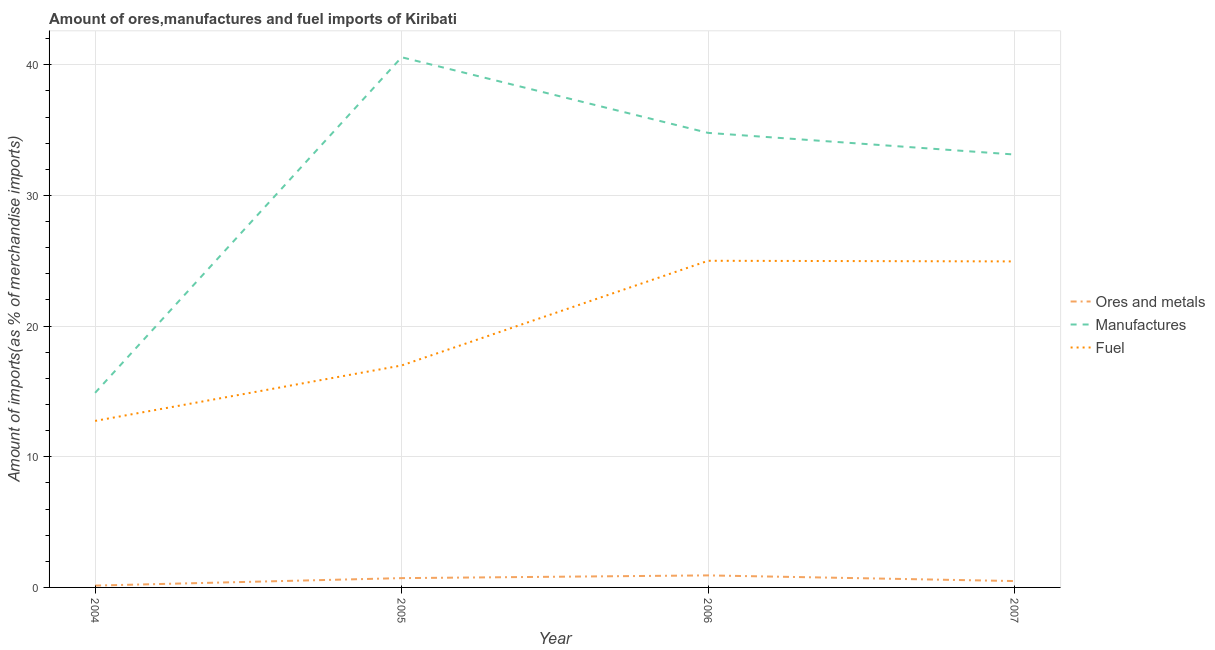How many different coloured lines are there?
Provide a succinct answer. 3. Does the line corresponding to percentage of manufactures imports intersect with the line corresponding to percentage of ores and metals imports?
Give a very brief answer. No. Is the number of lines equal to the number of legend labels?
Offer a terse response. Yes. What is the percentage of fuel imports in 2005?
Offer a terse response. 16.99. Across all years, what is the maximum percentage of manufactures imports?
Provide a succinct answer. 40.58. Across all years, what is the minimum percentage of ores and metals imports?
Your answer should be very brief. 0.14. What is the total percentage of manufactures imports in the graph?
Ensure brevity in your answer.  123.4. What is the difference between the percentage of ores and metals imports in 2004 and that in 2006?
Offer a terse response. -0.78. What is the difference between the percentage of fuel imports in 2007 and the percentage of manufactures imports in 2006?
Your response must be concise. -9.84. What is the average percentage of fuel imports per year?
Provide a succinct answer. 19.92. In the year 2004, what is the difference between the percentage of ores and metals imports and percentage of manufactures imports?
Provide a succinct answer. -14.75. What is the ratio of the percentage of fuel imports in 2004 to that in 2005?
Keep it short and to the point. 0.75. Is the percentage of manufactures imports in 2005 less than that in 2007?
Your answer should be compact. No. Is the difference between the percentage of ores and metals imports in 2005 and 2006 greater than the difference between the percentage of manufactures imports in 2005 and 2006?
Ensure brevity in your answer.  No. What is the difference between the highest and the second highest percentage of ores and metals imports?
Provide a short and direct response. 0.21. What is the difference between the highest and the lowest percentage of ores and metals imports?
Keep it short and to the point. 0.78. In how many years, is the percentage of fuel imports greater than the average percentage of fuel imports taken over all years?
Keep it short and to the point. 2. Is the sum of the percentage of ores and metals imports in 2006 and 2007 greater than the maximum percentage of fuel imports across all years?
Offer a terse response. No. Does the percentage of manufactures imports monotonically increase over the years?
Keep it short and to the point. No. Is the percentage of manufactures imports strictly less than the percentage of ores and metals imports over the years?
Give a very brief answer. No. How many lines are there?
Provide a succinct answer. 3. How many years are there in the graph?
Offer a very short reply. 4. What is the difference between two consecutive major ticks on the Y-axis?
Give a very brief answer. 10. Are the values on the major ticks of Y-axis written in scientific E-notation?
Offer a very short reply. No. Does the graph contain grids?
Your response must be concise. Yes. How many legend labels are there?
Keep it short and to the point. 3. What is the title of the graph?
Your response must be concise. Amount of ores,manufactures and fuel imports of Kiribati. Does "Textiles and clothing" appear as one of the legend labels in the graph?
Provide a succinct answer. No. What is the label or title of the X-axis?
Your answer should be compact. Year. What is the label or title of the Y-axis?
Give a very brief answer. Amount of imports(as % of merchandise imports). What is the Amount of imports(as % of merchandise imports) in Ores and metals in 2004?
Your response must be concise. 0.14. What is the Amount of imports(as % of merchandise imports) in Manufactures in 2004?
Provide a succinct answer. 14.89. What is the Amount of imports(as % of merchandise imports) of Fuel in 2004?
Your answer should be compact. 12.75. What is the Amount of imports(as % of merchandise imports) in Ores and metals in 2005?
Your answer should be very brief. 0.71. What is the Amount of imports(as % of merchandise imports) of Manufactures in 2005?
Give a very brief answer. 40.58. What is the Amount of imports(as % of merchandise imports) of Fuel in 2005?
Your answer should be very brief. 16.99. What is the Amount of imports(as % of merchandise imports) of Ores and metals in 2006?
Ensure brevity in your answer.  0.92. What is the Amount of imports(as % of merchandise imports) in Manufactures in 2006?
Provide a short and direct response. 34.79. What is the Amount of imports(as % of merchandise imports) of Fuel in 2006?
Your response must be concise. 25. What is the Amount of imports(as % of merchandise imports) of Ores and metals in 2007?
Your response must be concise. 0.49. What is the Amount of imports(as % of merchandise imports) in Manufactures in 2007?
Your answer should be very brief. 33.13. What is the Amount of imports(as % of merchandise imports) of Fuel in 2007?
Make the answer very short. 24.95. Across all years, what is the maximum Amount of imports(as % of merchandise imports) of Ores and metals?
Offer a terse response. 0.92. Across all years, what is the maximum Amount of imports(as % of merchandise imports) of Manufactures?
Your answer should be compact. 40.58. Across all years, what is the maximum Amount of imports(as % of merchandise imports) in Fuel?
Make the answer very short. 25. Across all years, what is the minimum Amount of imports(as % of merchandise imports) of Ores and metals?
Keep it short and to the point. 0.14. Across all years, what is the minimum Amount of imports(as % of merchandise imports) of Manufactures?
Your answer should be very brief. 14.89. Across all years, what is the minimum Amount of imports(as % of merchandise imports) in Fuel?
Provide a short and direct response. 12.75. What is the total Amount of imports(as % of merchandise imports) of Ores and metals in the graph?
Offer a terse response. 2.26. What is the total Amount of imports(as % of merchandise imports) in Manufactures in the graph?
Provide a short and direct response. 123.4. What is the total Amount of imports(as % of merchandise imports) of Fuel in the graph?
Make the answer very short. 79.69. What is the difference between the Amount of imports(as % of merchandise imports) in Ores and metals in 2004 and that in 2005?
Your answer should be compact. -0.57. What is the difference between the Amount of imports(as % of merchandise imports) in Manufactures in 2004 and that in 2005?
Provide a succinct answer. -25.69. What is the difference between the Amount of imports(as % of merchandise imports) of Fuel in 2004 and that in 2005?
Keep it short and to the point. -4.24. What is the difference between the Amount of imports(as % of merchandise imports) of Ores and metals in 2004 and that in 2006?
Provide a short and direct response. -0.78. What is the difference between the Amount of imports(as % of merchandise imports) of Manufactures in 2004 and that in 2006?
Provide a short and direct response. -19.9. What is the difference between the Amount of imports(as % of merchandise imports) in Fuel in 2004 and that in 2006?
Your answer should be compact. -12.26. What is the difference between the Amount of imports(as % of merchandise imports) of Ores and metals in 2004 and that in 2007?
Provide a succinct answer. -0.35. What is the difference between the Amount of imports(as % of merchandise imports) of Manufactures in 2004 and that in 2007?
Your answer should be compact. -18.24. What is the difference between the Amount of imports(as % of merchandise imports) of Fuel in 2004 and that in 2007?
Give a very brief answer. -12.21. What is the difference between the Amount of imports(as % of merchandise imports) of Ores and metals in 2005 and that in 2006?
Your answer should be very brief. -0.21. What is the difference between the Amount of imports(as % of merchandise imports) in Manufactures in 2005 and that in 2006?
Ensure brevity in your answer.  5.79. What is the difference between the Amount of imports(as % of merchandise imports) of Fuel in 2005 and that in 2006?
Your response must be concise. -8.01. What is the difference between the Amount of imports(as % of merchandise imports) of Ores and metals in 2005 and that in 2007?
Offer a very short reply. 0.22. What is the difference between the Amount of imports(as % of merchandise imports) of Manufactures in 2005 and that in 2007?
Your response must be concise. 7.45. What is the difference between the Amount of imports(as % of merchandise imports) of Fuel in 2005 and that in 2007?
Give a very brief answer. -7.96. What is the difference between the Amount of imports(as % of merchandise imports) of Ores and metals in 2006 and that in 2007?
Ensure brevity in your answer.  0.43. What is the difference between the Amount of imports(as % of merchandise imports) in Manufactures in 2006 and that in 2007?
Your response must be concise. 1.66. What is the difference between the Amount of imports(as % of merchandise imports) in Fuel in 2006 and that in 2007?
Ensure brevity in your answer.  0.05. What is the difference between the Amount of imports(as % of merchandise imports) in Ores and metals in 2004 and the Amount of imports(as % of merchandise imports) in Manufactures in 2005?
Offer a terse response. -40.44. What is the difference between the Amount of imports(as % of merchandise imports) in Ores and metals in 2004 and the Amount of imports(as % of merchandise imports) in Fuel in 2005?
Your answer should be very brief. -16.85. What is the difference between the Amount of imports(as % of merchandise imports) of Manufactures in 2004 and the Amount of imports(as % of merchandise imports) of Fuel in 2005?
Make the answer very short. -2.09. What is the difference between the Amount of imports(as % of merchandise imports) of Ores and metals in 2004 and the Amount of imports(as % of merchandise imports) of Manufactures in 2006?
Ensure brevity in your answer.  -34.65. What is the difference between the Amount of imports(as % of merchandise imports) of Ores and metals in 2004 and the Amount of imports(as % of merchandise imports) of Fuel in 2006?
Provide a short and direct response. -24.86. What is the difference between the Amount of imports(as % of merchandise imports) in Manufactures in 2004 and the Amount of imports(as % of merchandise imports) in Fuel in 2006?
Your answer should be very brief. -10.11. What is the difference between the Amount of imports(as % of merchandise imports) of Ores and metals in 2004 and the Amount of imports(as % of merchandise imports) of Manufactures in 2007?
Offer a terse response. -32.99. What is the difference between the Amount of imports(as % of merchandise imports) in Ores and metals in 2004 and the Amount of imports(as % of merchandise imports) in Fuel in 2007?
Your answer should be very brief. -24.81. What is the difference between the Amount of imports(as % of merchandise imports) of Manufactures in 2004 and the Amount of imports(as % of merchandise imports) of Fuel in 2007?
Offer a terse response. -10.06. What is the difference between the Amount of imports(as % of merchandise imports) in Ores and metals in 2005 and the Amount of imports(as % of merchandise imports) in Manufactures in 2006?
Your answer should be compact. -34.08. What is the difference between the Amount of imports(as % of merchandise imports) in Ores and metals in 2005 and the Amount of imports(as % of merchandise imports) in Fuel in 2006?
Offer a very short reply. -24.29. What is the difference between the Amount of imports(as % of merchandise imports) of Manufactures in 2005 and the Amount of imports(as % of merchandise imports) of Fuel in 2006?
Provide a succinct answer. 15.58. What is the difference between the Amount of imports(as % of merchandise imports) in Ores and metals in 2005 and the Amount of imports(as % of merchandise imports) in Manufactures in 2007?
Your response must be concise. -32.42. What is the difference between the Amount of imports(as % of merchandise imports) in Ores and metals in 2005 and the Amount of imports(as % of merchandise imports) in Fuel in 2007?
Make the answer very short. -24.24. What is the difference between the Amount of imports(as % of merchandise imports) in Manufactures in 2005 and the Amount of imports(as % of merchandise imports) in Fuel in 2007?
Provide a short and direct response. 15.63. What is the difference between the Amount of imports(as % of merchandise imports) of Ores and metals in 2006 and the Amount of imports(as % of merchandise imports) of Manufactures in 2007?
Your answer should be very brief. -32.21. What is the difference between the Amount of imports(as % of merchandise imports) in Ores and metals in 2006 and the Amount of imports(as % of merchandise imports) in Fuel in 2007?
Provide a succinct answer. -24.03. What is the difference between the Amount of imports(as % of merchandise imports) of Manufactures in 2006 and the Amount of imports(as % of merchandise imports) of Fuel in 2007?
Provide a short and direct response. 9.84. What is the average Amount of imports(as % of merchandise imports) of Ores and metals per year?
Your response must be concise. 0.57. What is the average Amount of imports(as % of merchandise imports) in Manufactures per year?
Ensure brevity in your answer.  30.85. What is the average Amount of imports(as % of merchandise imports) of Fuel per year?
Give a very brief answer. 19.92. In the year 2004, what is the difference between the Amount of imports(as % of merchandise imports) of Ores and metals and Amount of imports(as % of merchandise imports) of Manufactures?
Offer a very short reply. -14.75. In the year 2004, what is the difference between the Amount of imports(as % of merchandise imports) in Ores and metals and Amount of imports(as % of merchandise imports) in Fuel?
Your answer should be compact. -12.61. In the year 2004, what is the difference between the Amount of imports(as % of merchandise imports) in Manufactures and Amount of imports(as % of merchandise imports) in Fuel?
Provide a short and direct response. 2.15. In the year 2005, what is the difference between the Amount of imports(as % of merchandise imports) in Ores and metals and Amount of imports(as % of merchandise imports) in Manufactures?
Give a very brief answer. -39.87. In the year 2005, what is the difference between the Amount of imports(as % of merchandise imports) in Ores and metals and Amount of imports(as % of merchandise imports) in Fuel?
Offer a very short reply. -16.28. In the year 2005, what is the difference between the Amount of imports(as % of merchandise imports) of Manufactures and Amount of imports(as % of merchandise imports) of Fuel?
Make the answer very short. 23.59. In the year 2006, what is the difference between the Amount of imports(as % of merchandise imports) of Ores and metals and Amount of imports(as % of merchandise imports) of Manufactures?
Ensure brevity in your answer.  -33.87. In the year 2006, what is the difference between the Amount of imports(as % of merchandise imports) in Ores and metals and Amount of imports(as % of merchandise imports) in Fuel?
Keep it short and to the point. -24.08. In the year 2006, what is the difference between the Amount of imports(as % of merchandise imports) in Manufactures and Amount of imports(as % of merchandise imports) in Fuel?
Your answer should be very brief. 9.79. In the year 2007, what is the difference between the Amount of imports(as % of merchandise imports) in Ores and metals and Amount of imports(as % of merchandise imports) in Manufactures?
Give a very brief answer. -32.65. In the year 2007, what is the difference between the Amount of imports(as % of merchandise imports) of Ores and metals and Amount of imports(as % of merchandise imports) of Fuel?
Make the answer very short. -24.46. In the year 2007, what is the difference between the Amount of imports(as % of merchandise imports) of Manufactures and Amount of imports(as % of merchandise imports) of Fuel?
Provide a succinct answer. 8.18. What is the ratio of the Amount of imports(as % of merchandise imports) of Ores and metals in 2004 to that in 2005?
Offer a very short reply. 0.2. What is the ratio of the Amount of imports(as % of merchandise imports) in Manufactures in 2004 to that in 2005?
Provide a short and direct response. 0.37. What is the ratio of the Amount of imports(as % of merchandise imports) in Fuel in 2004 to that in 2005?
Make the answer very short. 0.75. What is the ratio of the Amount of imports(as % of merchandise imports) of Ores and metals in 2004 to that in 2006?
Provide a short and direct response. 0.15. What is the ratio of the Amount of imports(as % of merchandise imports) in Manufactures in 2004 to that in 2006?
Keep it short and to the point. 0.43. What is the ratio of the Amount of imports(as % of merchandise imports) in Fuel in 2004 to that in 2006?
Make the answer very short. 0.51. What is the ratio of the Amount of imports(as % of merchandise imports) in Ores and metals in 2004 to that in 2007?
Provide a succinct answer. 0.29. What is the ratio of the Amount of imports(as % of merchandise imports) of Manufactures in 2004 to that in 2007?
Offer a terse response. 0.45. What is the ratio of the Amount of imports(as % of merchandise imports) of Fuel in 2004 to that in 2007?
Your answer should be compact. 0.51. What is the ratio of the Amount of imports(as % of merchandise imports) in Ores and metals in 2005 to that in 2006?
Offer a very short reply. 0.77. What is the ratio of the Amount of imports(as % of merchandise imports) of Manufactures in 2005 to that in 2006?
Offer a very short reply. 1.17. What is the ratio of the Amount of imports(as % of merchandise imports) in Fuel in 2005 to that in 2006?
Offer a terse response. 0.68. What is the ratio of the Amount of imports(as % of merchandise imports) in Ores and metals in 2005 to that in 2007?
Offer a terse response. 1.46. What is the ratio of the Amount of imports(as % of merchandise imports) in Manufactures in 2005 to that in 2007?
Provide a short and direct response. 1.22. What is the ratio of the Amount of imports(as % of merchandise imports) of Fuel in 2005 to that in 2007?
Keep it short and to the point. 0.68. What is the ratio of the Amount of imports(as % of merchandise imports) of Ores and metals in 2006 to that in 2007?
Provide a short and direct response. 1.89. What is the ratio of the Amount of imports(as % of merchandise imports) of Manufactures in 2006 to that in 2007?
Provide a short and direct response. 1.05. What is the difference between the highest and the second highest Amount of imports(as % of merchandise imports) in Ores and metals?
Your response must be concise. 0.21. What is the difference between the highest and the second highest Amount of imports(as % of merchandise imports) in Manufactures?
Your response must be concise. 5.79. What is the difference between the highest and the second highest Amount of imports(as % of merchandise imports) of Fuel?
Provide a short and direct response. 0.05. What is the difference between the highest and the lowest Amount of imports(as % of merchandise imports) in Ores and metals?
Make the answer very short. 0.78. What is the difference between the highest and the lowest Amount of imports(as % of merchandise imports) of Manufactures?
Offer a very short reply. 25.69. What is the difference between the highest and the lowest Amount of imports(as % of merchandise imports) in Fuel?
Provide a short and direct response. 12.26. 